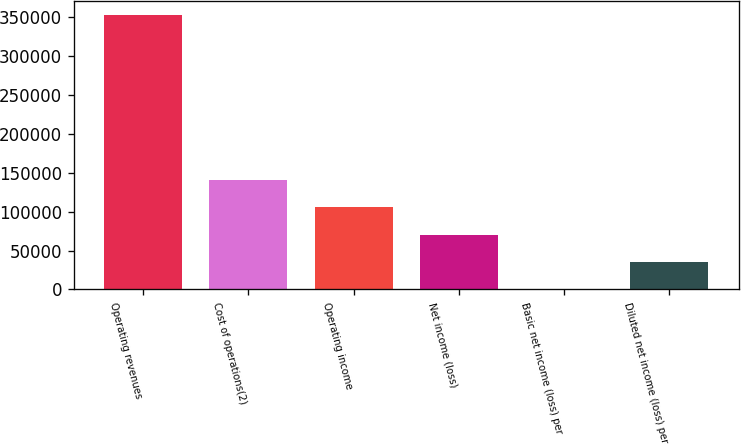Convert chart to OTSL. <chart><loc_0><loc_0><loc_500><loc_500><bar_chart><fcel>Operating revenues<fcel>Cost of operations(2)<fcel>Operating income<fcel>Net income (loss)<fcel>Basic net income (loss) per<fcel>Diluted net income (loss) per<nl><fcel>352474<fcel>140990<fcel>105742<fcel>70494.9<fcel>0.05<fcel>35247.4<nl></chart> 